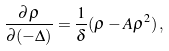<formula> <loc_0><loc_0><loc_500><loc_500>\frac { \partial \rho } { \partial ( - \Delta ) } = \frac { 1 } { \delta } ( \rho - A \rho ^ { 2 } ) \, ,</formula> 